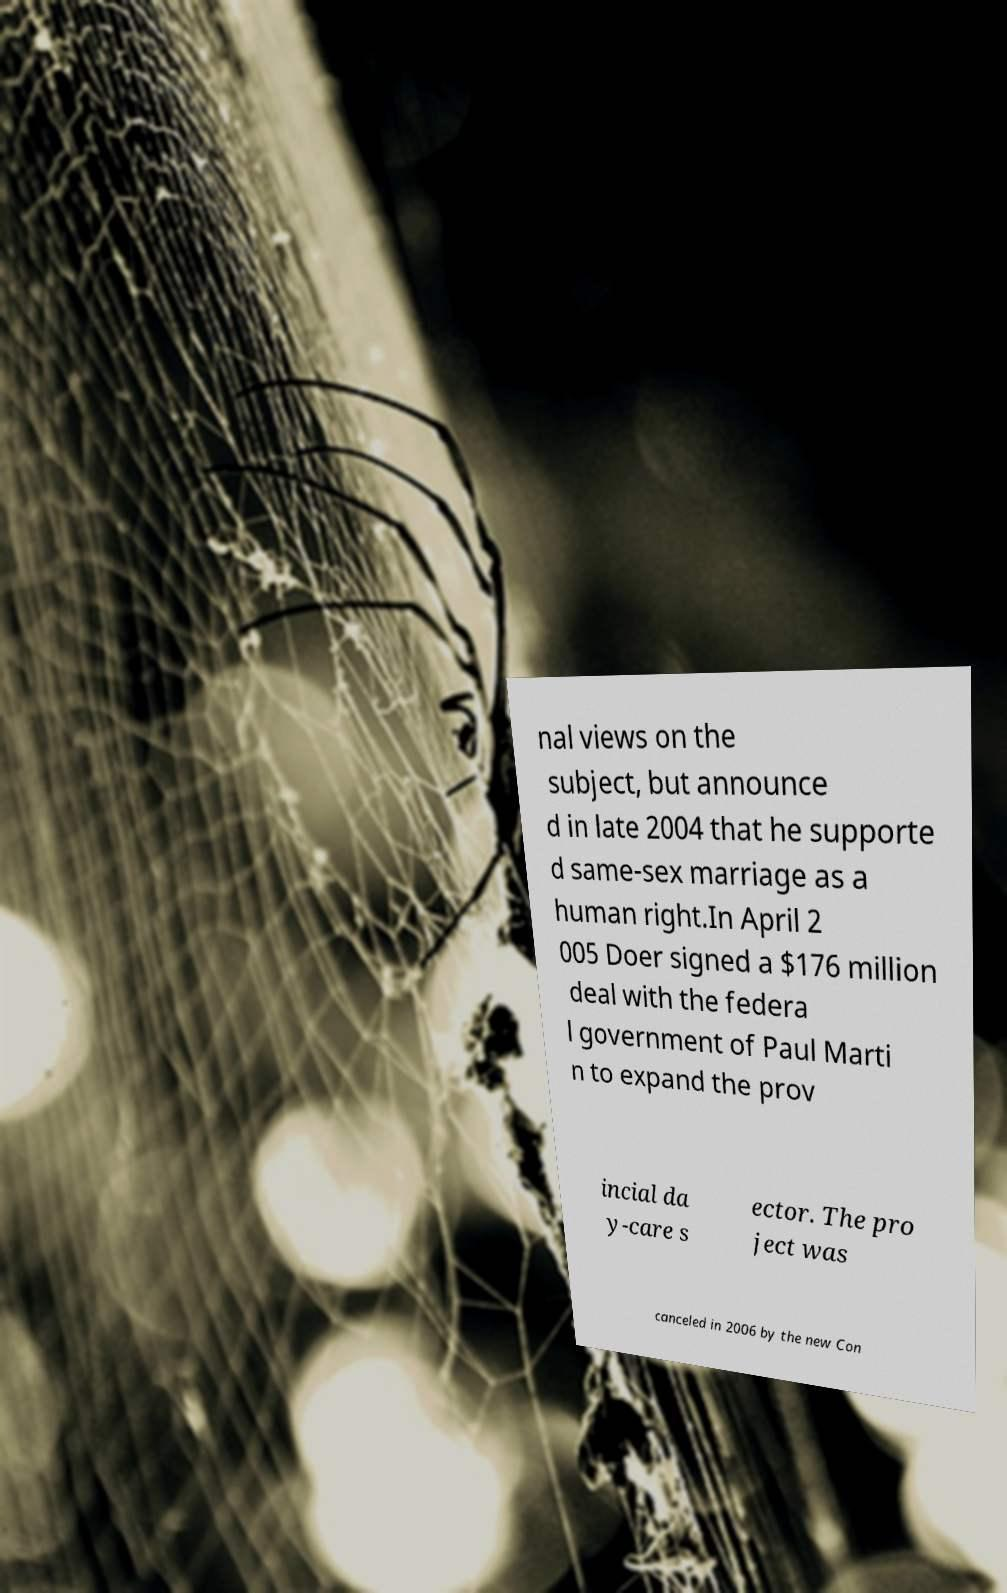Please identify and transcribe the text found in this image. nal views on the subject, but announce d in late 2004 that he supporte d same-sex marriage as a human right.In April 2 005 Doer signed a $176 million deal with the federa l government of Paul Marti n to expand the prov incial da y-care s ector. The pro ject was canceled in 2006 by the new Con 